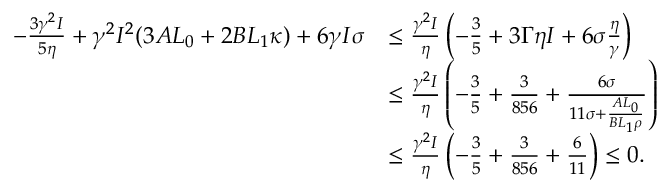Convert formula to latex. <formula><loc_0><loc_0><loc_500><loc_500>\begin{array} { r l } { - \frac { 3 \gamma ^ { 2 } I } { 5 \eta } + \gamma ^ { 2 } I ^ { 2 } ( 3 A L _ { 0 } + 2 B L _ { 1 } \kappa ) + 6 \gamma I \sigma } & { \leq \frac { \gamma ^ { 2 } I } { \eta } \left ( - \frac { 3 } { 5 } + 3 \Gamma \eta I + 6 \sigma \frac { \eta } { \gamma } \right ) } \\ & { \leq \frac { \gamma ^ { 2 } I } { \eta } \left ( - \frac { 3 } { 5 } + \frac { 3 } { 8 5 6 } + \frac { 6 \sigma } { 1 1 \sigma + \frac { A L _ { 0 } } { B L _ { 1 } \rho } } \right ) } \\ & { \leq \frac { \gamma ^ { 2 } I } { \eta } \left ( - \frac { 3 } { 5 } + \frac { 3 } { 8 5 6 } + \frac { 6 } { 1 1 } \right ) \leq 0 . } \end{array}</formula> 